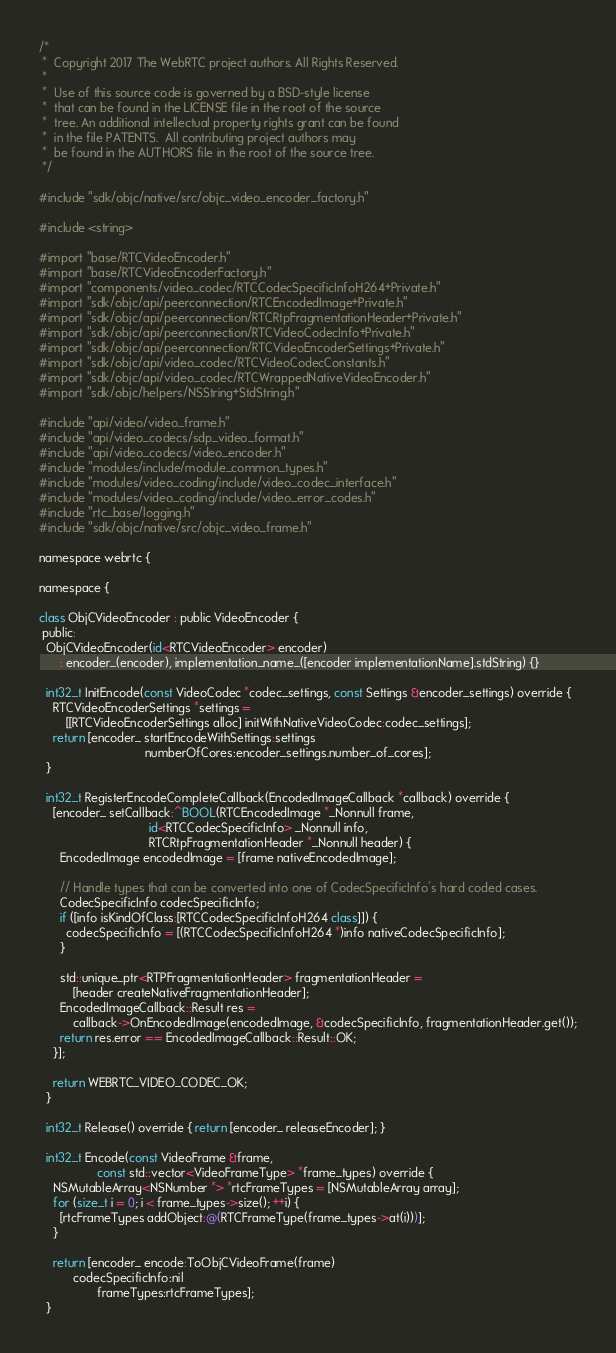<code> <loc_0><loc_0><loc_500><loc_500><_ObjectiveC_>/*
 *  Copyright 2017 The WebRTC project authors. All Rights Reserved.
 *
 *  Use of this source code is governed by a BSD-style license
 *  that can be found in the LICENSE file in the root of the source
 *  tree. An additional intellectual property rights grant can be found
 *  in the file PATENTS.  All contributing project authors may
 *  be found in the AUTHORS file in the root of the source tree.
 */

#include "sdk/objc/native/src/objc_video_encoder_factory.h"

#include <string>

#import "base/RTCVideoEncoder.h"
#import "base/RTCVideoEncoderFactory.h"
#import "components/video_codec/RTCCodecSpecificInfoH264+Private.h"
#import "sdk/objc/api/peerconnection/RTCEncodedImage+Private.h"
#import "sdk/objc/api/peerconnection/RTCRtpFragmentationHeader+Private.h"
#import "sdk/objc/api/peerconnection/RTCVideoCodecInfo+Private.h"
#import "sdk/objc/api/peerconnection/RTCVideoEncoderSettings+Private.h"
#import "sdk/objc/api/video_codec/RTCVideoCodecConstants.h"
#import "sdk/objc/api/video_codec/RTCWrappedNativeVideoEncoder.h"
#import "sdk/objc/helpers/NSString+StdString.h"

#include "api/video/video_frame.h"
#include "api/video_codecs/sdp_video_format.h"
#include "api/video_codecs/video_encoder.h"
#include "modules/include/module_common_types.h"
#include "modules/video_coding/include/video_codec_interface.h"
#include "modules/video_coding/include/video_error_codes.h"
#include "rtc_base/logging.h"
#include "sdk/objc/native/src/objc_video_frame.h"

namespace webrtc {

namespace {

class ObjCVideoEncoder : public VideoEncoder {
 public:
  ObjCVideoEncoder(id<RTCVideoEncoder> encoder)
      : encoder_(encoder), implementation_name_([encoder implementationName].stdString) {}

  int32_t InitEncode(const VideoCodec *codec_settings, const Settings &encoder_settings) override {
    RTCVideoEncoderSettings *settings =
        [[RTCVideoEncoderSettings alloc] initWithNativeVideoCodec:codec_settings];
    return [encoder_ startEncodeWithSettings:settings
                               numberOfCores:encoder_settings.number_of_cores];
  }

  int32_t RegisterEncodeCompleteCallback(EncodedImageCallback *callback) override {
    [encoder_ setCallback:^BOOL(RTCEncodedImage *_Nonnull frame,
                                id<RTCCodecSpecificInfo> _Nonnull info,
                                RTCRtpFragmentationHeader *_Nonnull header) {
      EncodedImage encodedImage = [frame nativeEncodedImage];

      // Handle types that can be converted into one of CodecSpecificInfo's hard coded cases.
      CodecSpecificInfo codecSpecificInfo;
      if ([info isKindOfClass:[RTCCodecSpecificInfoH264 class]]) {
        codecSpecificInfo = [(RTCCodecSpecificInfoH264 *)info nativeCodecSpecificInfo];
      }

      std::unique_ptr<RTPFragmentationHeader> fragmentationHeader =
          [header createNativeFragmentationHeader];
      EncodedImageCallback::Result res =
          callback->OnEncodedImage(encodedImage, &codecSpecificInfo, fragmentationHeader.get());
      return res.error == EncodedImageCallback::Result::OK;
    }];

    return WEBRTC_VIDEO_CODEC_OK;
  }

  int32_t Release() override { return [encoder_ releaseEncoder]; }

  int32_t Encode(const VideoFrame &frame,
                 const std::vector<VideoFrameType> *frame_types) override {
    NSMutableArray<NSNumber *> *rtcFrameTypes = [NSMutableArray array];
    for (size_t i = 0; i < frame_types->size(); ++i) {
      [rtcFrameTypes addObject:@(RTCFrameType(frame_types->at(i)))];
    }

    return [encoder_ encode:ToObjCVideoFrame(frame)
          codecSpecificInfo:nil
                 frameTypes:rtcFrameTypes];
  }
</code> 